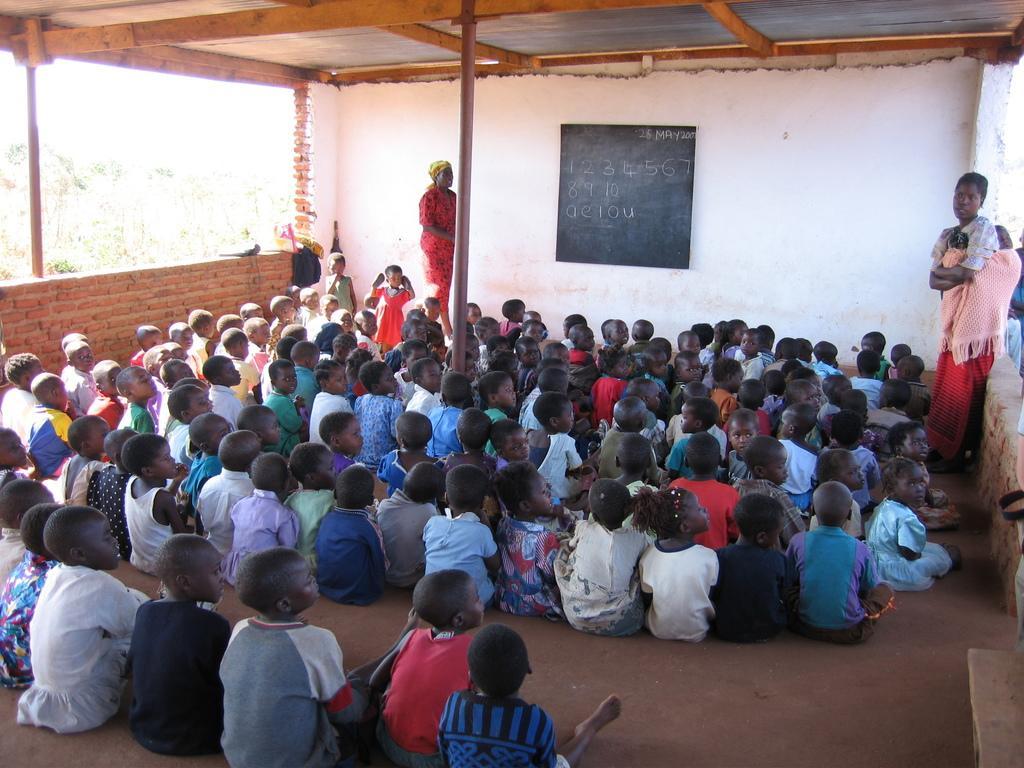Could you give a brief overview of what you see in this image? In this image there is a classroom. Many kids are sitting. In the right a lady is standing. In the background there is a blackboard. On it there are numbers are written. A lady is standing. Two kids are standing here. Here there are few bags. In the background there are trees. 